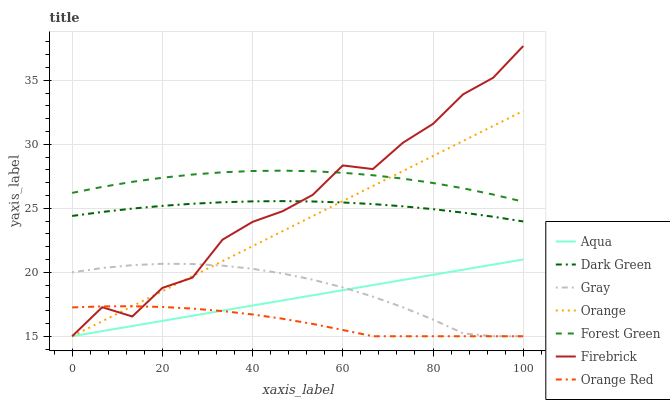Does Orange Red have the minimum area under the curve?
Answer yes or no. Yes. Does Forest Green have the maximum area under the curve?
Answer yes or no. Yes. Does Firebrick have the minimum area under the curve?
Answer yes or no. No. Does Firebrick have the maximum area under the curve?
Answer yes or no. No. Is Aqua the smoothest?
Answer yes or no. Yes. Is Firebrick the roughest?
Answer yes or no. Yes. Is Firebrick the smoothest?
Answer yes or no. No. Is Aqua the roughest?
Answer yes or no. No. Does Gray have the lowest value?
Answer yes or no. Yes. Does Forest Green have the lowest value?
Answer yes or no. No. Does Firebrick have the highest value?
Answer yes or no. Yes. Does Aqua have the highest value?
Answer yes or no. No. Is Orange Red less than Dark Green?
Answer yes or no. Yes. Is Forest Green greater than Aqua?
Answer yes or no. Yes. Does Orange intersect Forest Green?
Answer yes or no. Yes. Is Orange less than Forest Green?
Answer yes or no. No. Is Orange greater than Forest Green?
Answer yes or no. No. Does Orange Red intersect Dark Green?
Answer yes or no. No. 